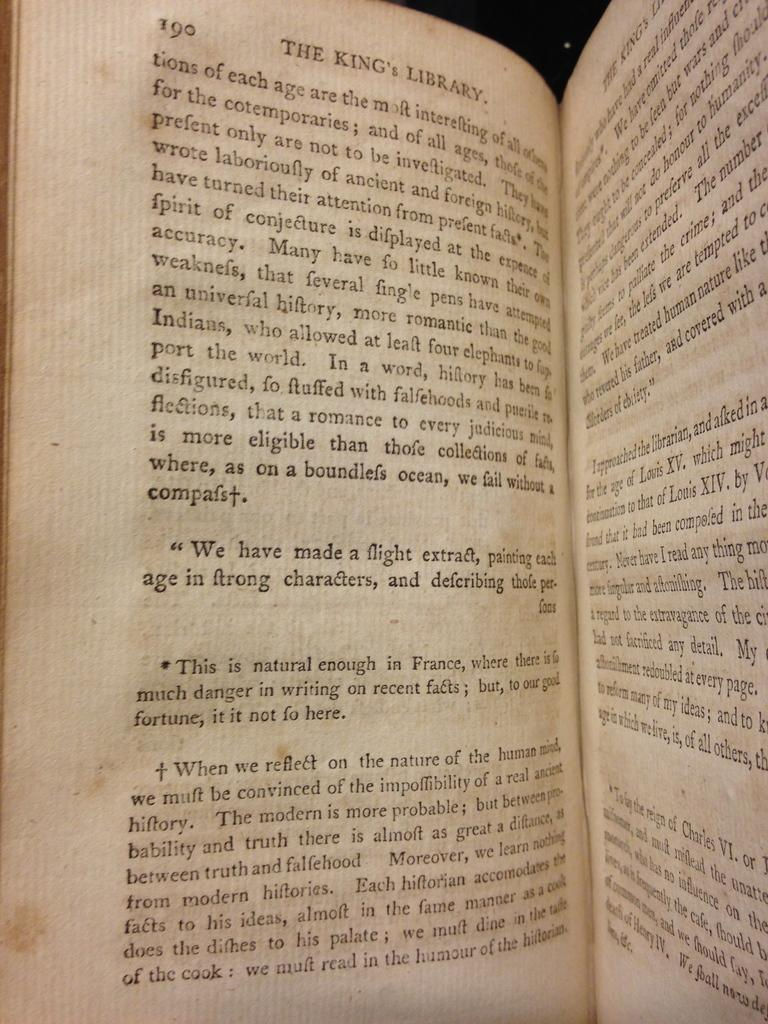<image>
Give a short and clear explanation of the subsequent image. The King's Library that is opened to page 190. 